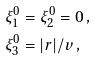Convert formula to latex. <formula><loc_0><loc_0><loc_500><loc_500>\xi _ { 1 } ^ { 0 } & = \xi _ { 2 } ^ { 0 } = 0 \, , \\ \xi _ { 3 } ^ { 0 } & = | r | / v \, ,</formula> 